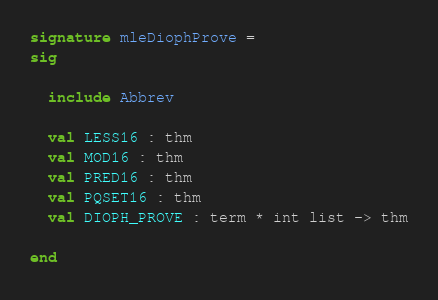<code> <loc_0><loc_0><loc_500><loc_500><_SML_>signature mleDiophProve =
sig

  include Abbrev

  val LESS16 : thm
  val MOD16 : thm
  val PRED16 : thm
  val PQSET16 : thm
  val DIOPH_PROVE : term * int list -> thm

end
</code> 